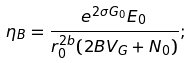Convert formula to latex. <formula><loc_0><loc_0><loc_500><loc_500>\eta _ { B } = \frac { e ^ { 2 \sigma G _ { 0 } } E _ { 0 } } { r _ { 0 } ^ { 2 b } ( 2 B V _ { G } + N _ { 0 } ) } ;</formula> 